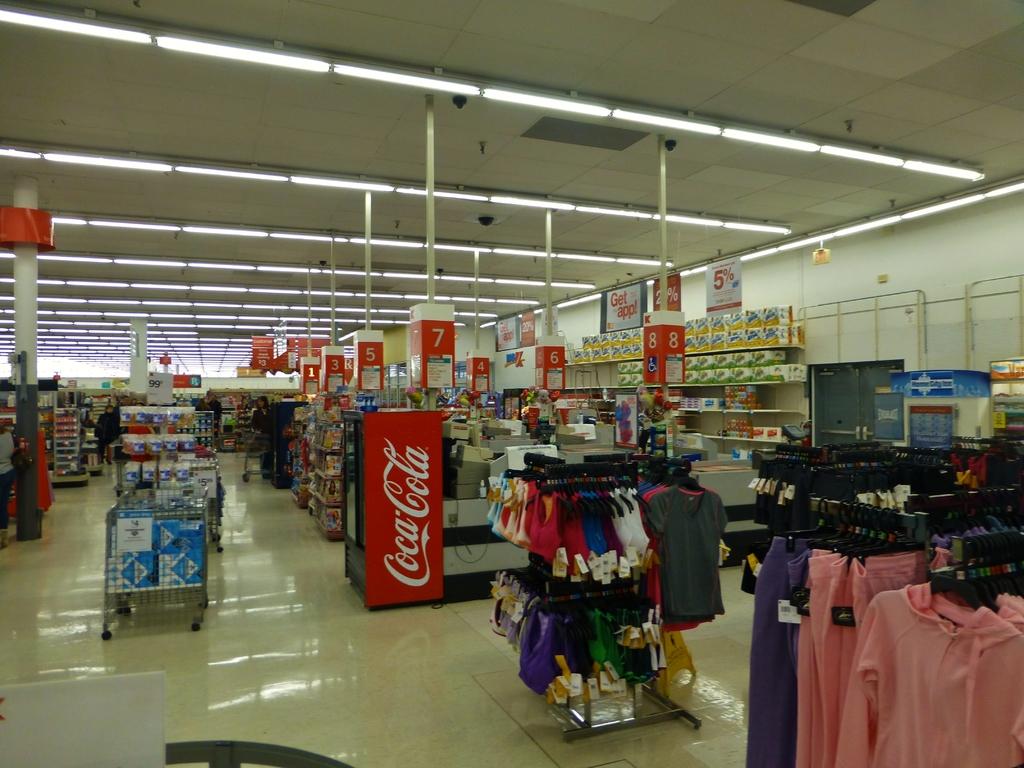What soda company is on the side of the cooler?
Offer a terse response. Coca cola. What aisle number is directly above the coca-cola machine?
Ensure brevity in your answer.  7. 